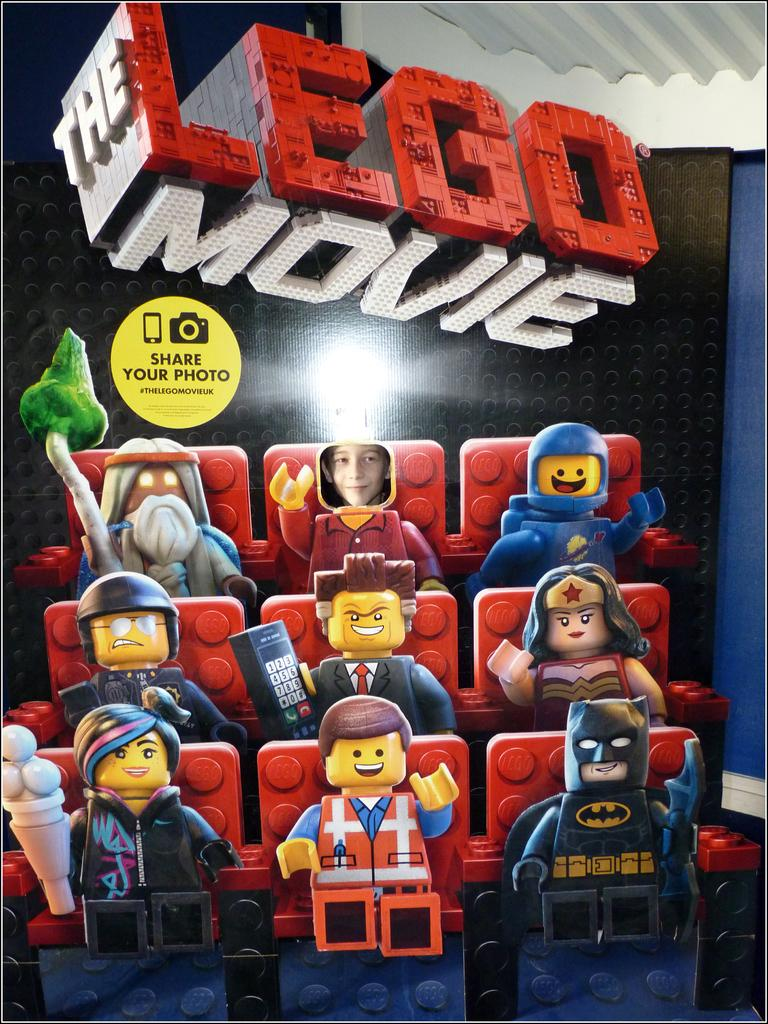What objects are present in the image? There are toys in the image. Where are the toys located in relation to other elements in the image? The toys are placed near a wall. What part of a building can be seen in the image? The top right corner of the image shows a roof. What type of animal can be seen wearing a mitten in the image? There is no animal or mitten present in the image. 